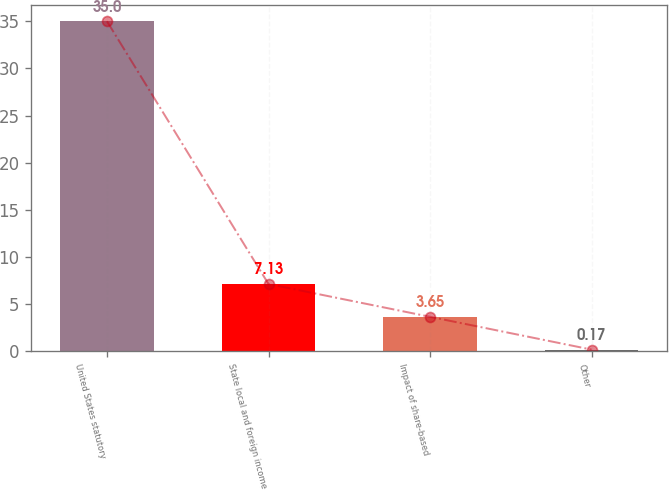<chart> <loc_0><loc_0><loc_500><loc_500><bar_chart><fcel>United States statutory<fcel>State local and foreign income<fcel>Impact of share-based<fcel>Other<nl><fcel>35<fcel>7.13<fcel>3.65<fcel>0.17<nl></chart> 